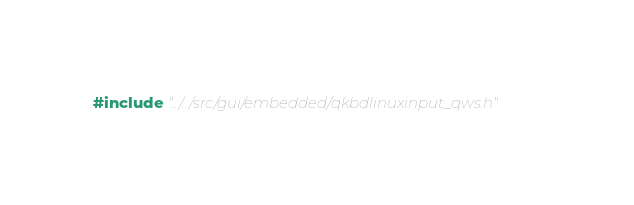<code> <loc_0><loc_0><loc_500><loc_500><_C_>#include "../../src/gui/embedded/qkbdlinuxinput_qws.h"
</code> 